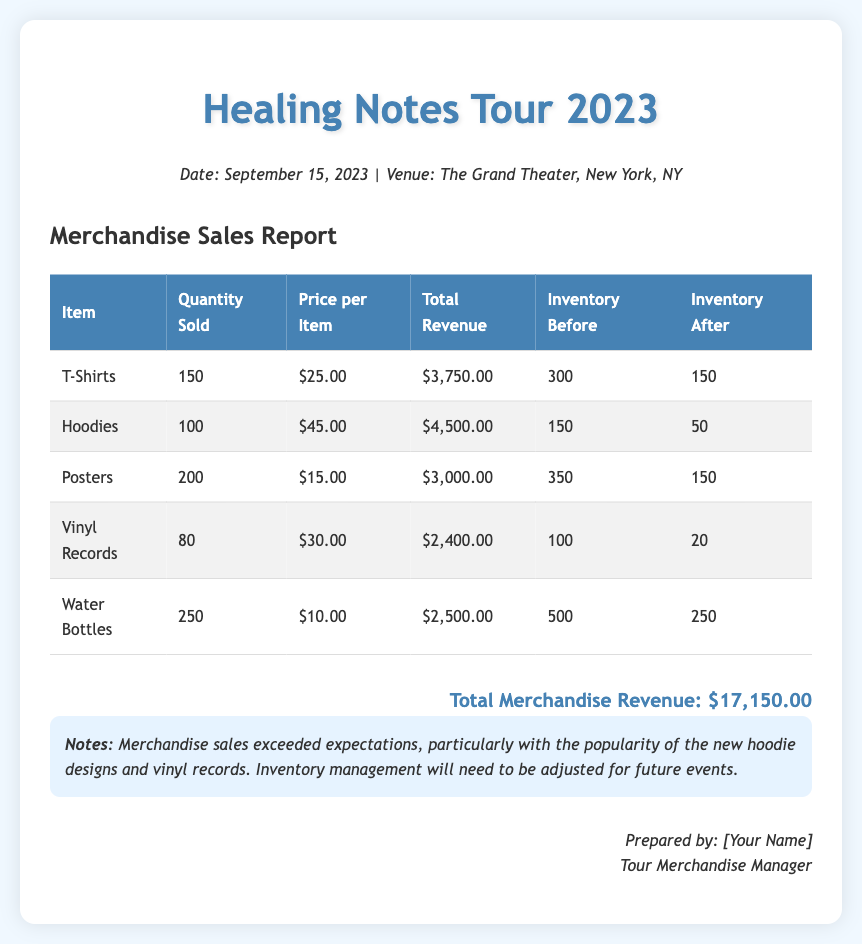What is the total quantity of T-Shirts sold? The quantity sold is directly listed in the document under the T-Shirts entry, which shows 150.
Answer: 150 What was the price per hoodie? The price for hoodies is specified in the document under the Hoodies entry, which is $45.00.
Answer: $45.00 How much total revenue did posters generate? The total revenue from posters can be found under the Posters entry, which states $3,000.00.
Answer: $3,000.00 What item had the highest revenue? By comparing the total revenue figures for all items, hoodies generated the highest revenue at $4,500.00.
Answer: Hoodies What is the remaining inventory for vinyl records? The document shows the inventory after sales for vinyl records, which is 20.
Answer: 20 What is the date of the concert? The date of the concert is mentioned at the top of the document as September 15, 2023.
Answer: September 15, 2023 How many water bottles were sold? The sold quantity of water bottles is listed directly, which is 250.
Answer: 250 What is the total merchandise revenue? The total revenue is summarized at the bottom of the document, showing $17,150.00.
Answer: $17,150.00 What notes were provided about merchandise sales? The notes section indicates that sales exceeded expectations, especially for hoodies and vinyl records.
Answer: Sales exceeded expectations 